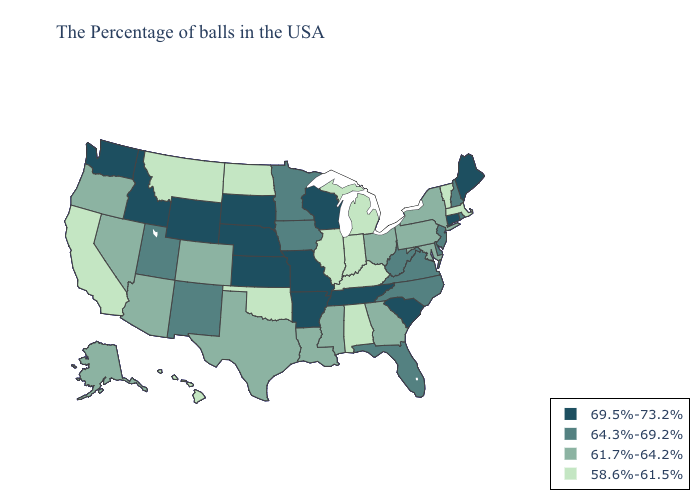Among the states that border Vermont , does New Hampshire have the highest value?
Short answer required. Yes. Does the map have missing data?
Quick response, please. No. What is the highest value in states that border Nevada?
Concise answer only. 69.5%-73.2%. Does Georgia have the highest value in the South?
Concise answer only. No. What is the value of Tennessee?
Write a very short answer. 69.5%-73.2%. Name the states that have a value in the range 58.6%-61.5%?
Short answer required. Massachusetts, Vermont, Michigan, Kentucky, Indiana, Alabama, Illinois, Oklahoma, North Dakota, Montana, California, Hawaii. Which states have the lowest value in the South?
Write a very short answer. Kentucky, Alabama, Oklahoma. What is the value of Massachusetts?
Answer briefly. 58.6%-61.5%. What is the value of Virginia?
Write a very short answer. 64.3%-69.2%. Name the states that have a value in the range 64.3%-69.2%?
Be succinct. Rhode Island, New Hampshire, New Jersey, Delaware, Virginia, North Carolina, West Virginia, Florida, Minnesota, Iowa, New Mexico, Utah. What is the highest value in the USA?
Short answer required. 69.5%-73.2%. What is the highest value in the South ?
Answer briefly. 69.5%-73.2%. Name the states that have a value in the range 69.5%-73.2%?
Write a very short answer. Maine, Connecticut, South Carolina, Tennessee, Wisconsin, Missouri, Arkansas, Kansas, Nebraska, South Dakota, Wyoming, Idaho, Washington. What is the value of Louisiana?
Keep it brief. 61.7%-64.2%. Which states have the lowest value in the USA?
Be succinct. Massachusetts, Vermont, Michigan, Kentucky, Indiana, Alabama, Illinois, Oklahoma, North Dakota, Montana, California, Hawaii. 